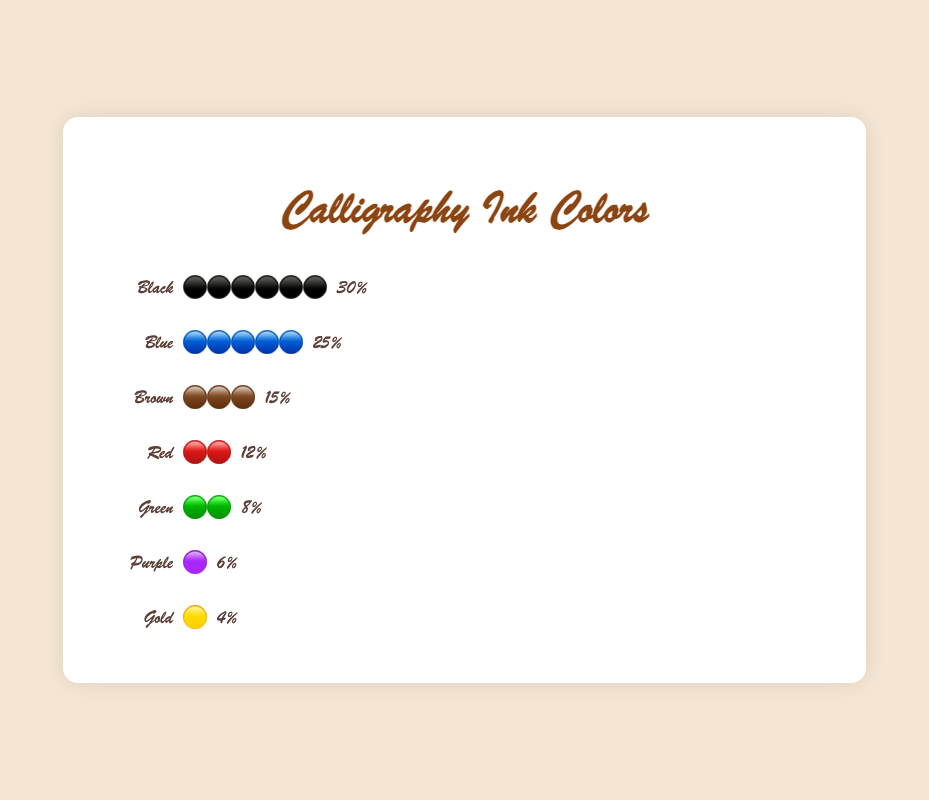what is the percentage of Black ink usage? The figure shows a bar for Black ink with a percentage value next to it. By seeing this bar and percentage value, you can determine the percentage of Black ink usage.
Answer: 30% What is the second most-used ink color in calligraphy? The figure has percentages next to each ink color. The second highest value is 25% next to Blue ink. Thus, Blue is the second most-used ink color.
Answer: Blue What are the three least-used ink colors, and what are their percentages? The figure lists ink colors in descending order of usage. The three colors with the smallest bars and percentages are Gold (4%), Purple (6%), and Green (8%).
Answer: Gold (4%), Purple (6%), Green (8%) Which colors have usage percentages greater than 10%? The figure shows percentages next to each color. The colors with percentages greater than 10% are Black (30%), Blue (25%), Brown (15%), and Red (12%).
Answer: Black, Blue, Brown, Red How much more percentage is Black used compared to Green ink? The percentage of Black ink is 30% and Green ink is 8%. Subtracting these two values, 30% - 8% = 22%.
Answer: 22% How many emoji circles are used to represent Blue ink? Each emoji circle represents 5% usage. Blue ink is used 25%, which would result in 25 / 5 = 5 emoji circles.
Answer: 5 If you combine Brown, Red, and Green ink usages, what would be the total percentage? The individual percentages are Brown (15%), Red (12%), and Green (8%). Adding these together, 15% + 12% + 8% = 35%.
Answer: 35% Which ink color has the shortest emoji bar and what is its length in the figure? The shortest emoji bar corresponds to the smallest percentage. The figure shows Gold with a 4% usage represented by one emoji circle (since each circle represents 5%).
Answer: Gold, 1 circle What is the combined usage percentage of the top two most-used ink colors? The top two ink colors are Black (30%) and Blue (25%). Combining these gives 30% + 25% = 55%.
Answer: 55% What is the percentage difference between Blue and Brown ink usages? Blue ink is used 25% and Brown ink is used 15%. The difference is 25% - 15% = 10%.
Answer: 10% 